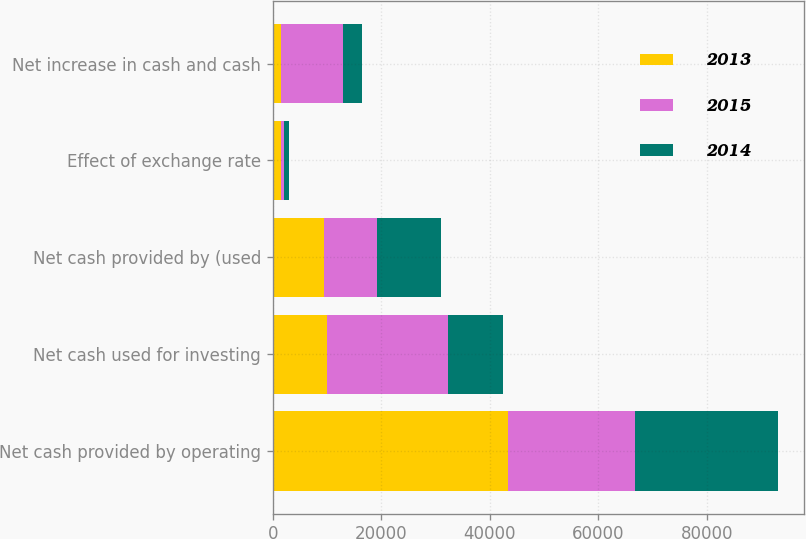Convert chart. <chart><loc_0><loc_0><loc_500><loc_500><stacked_bar_chart><ecel><fcel>Net cash provided by operating<fcel>Net cash used for investing<fcel>Net cash provided by (used<fcel>Effect of exchange rate<fcel>Net increase in cash and cash<nl><fcel>2013<fcel>43279<fcel>9948.5<fcel>9534<fcel>1465<fcel>1485<nl><fcel>2015<fcel>23466<fcel>22272<fcel>9632<fcel>639<fcel>11465<nl><fcel>2014<fcel>26399<fcel>10265<fcel>11811<fcel>862<fcel>3461<nl></chart> 